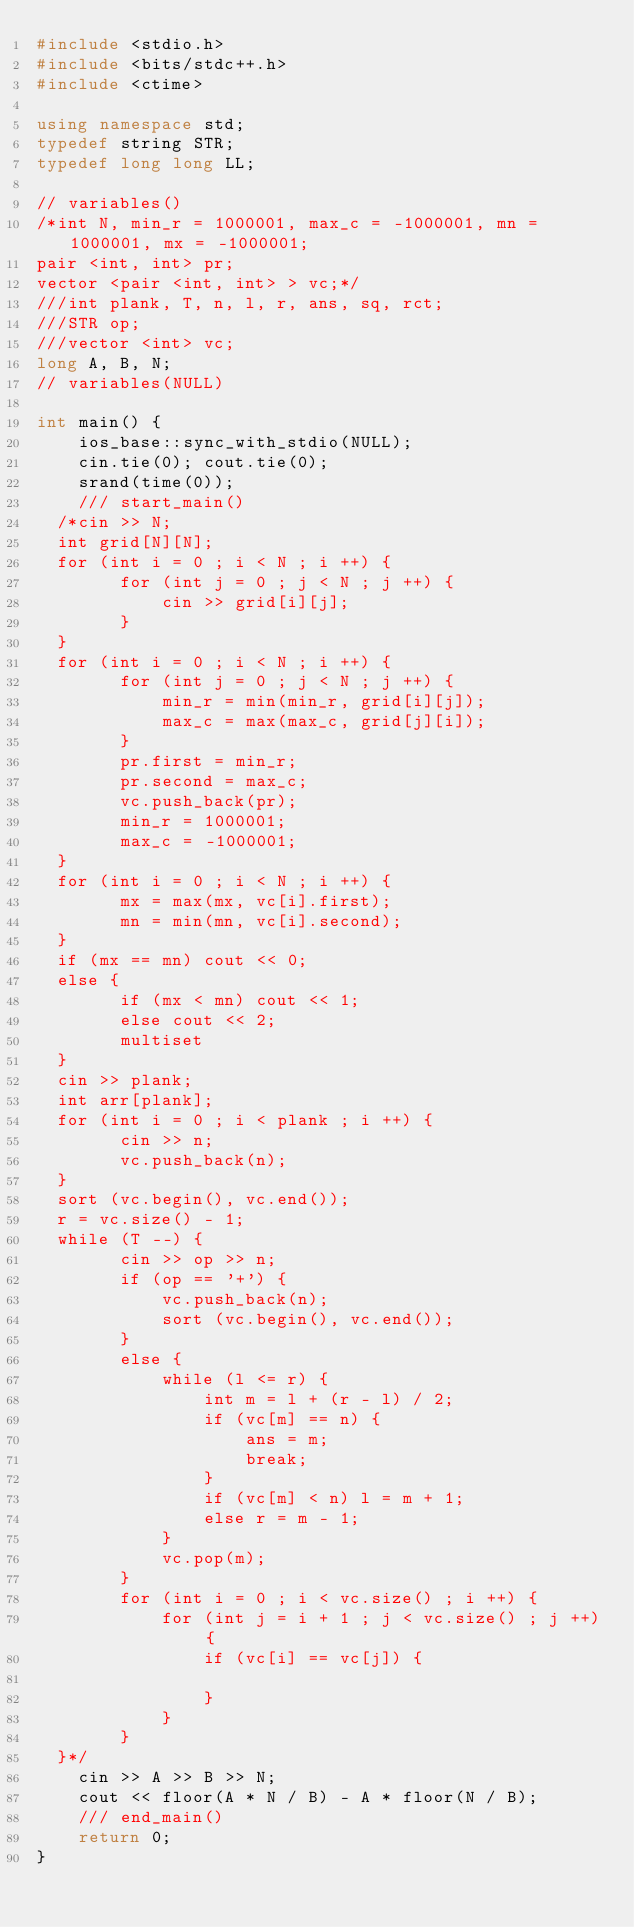<code> <loc_0><loc_0><loc_500><loc_500><_C++_>#include <stdio.h>
#include <bits/stdc++.h>
#include <ctime>

using namespace std;
typedef string STR;
typedef long long LL;

// variables()
/*int N, min_r = 1000001, max_c = -1000001, mn = 1000001, mx = -1000001;
pair <int, int> pr;
vector <pair <int, int> > vc;*/
///int plank, T, n, l, r, ans, sq, rct;
///STR op;
///vector <int> vc;
long A, B, N;
// variables(NULL)

int main() {
    ios_base::sync_with_stdio(NULL);
    cin.tie(0); cout.tie(0);
    srand(time(0));
    /// start_main()
	/*cin >> N;
	int grid[N][N];
	for (int i = 0 ; i < N ; i ++) {
        for (int j = 0 ; j < N ; j ++) {
            cin >> grid[i][j];
        }
	}
	for (int i = 0 ; i < N ; i ++) {
        for (int j = 0 ; j < N ; j ++) {
            min_r = min(min_r, grid[i][j]);
            max_c = max(max_c, grid[j][i]);
        }
        pr.first = min_r;
        pr.second = max_c;
        vc.push_back(pr);
        min_r = 1000001;
        max_c = -1000001;
	}
	for (int i = 0 ; i < N ; i ++) {
        mx = max(mx, vc[i].first);
        mn = min(mn, vc[i].second);
	}
	if (mx == mn) cout << 0;
	else {
        if (mx < mn) cout << 1;
        else cout << 2;
        multiset
	}
	cin >> plank;
	int arr[plank];
	for (int i = 0 ; i < plank ; i ++) {
        cin >> n;
        vc.push_back(n);
	}
	sort (vc.begin(), vc.end());
	r = vc.size() - 1;
	while (T --) {
        cin >> op >> n;
        if (op == '+') {
            vc.push_back(n);
            sort (vc.begin(), vc.end());
        }
        else {
            while (l <= r) {
                int m = l + (r - l) / 2;
                if (vc[m] == n) {
                    ans = m;
                    break;
                }
                if (vc[m] < n) l = m + 1;
                else r = m - 1;
            }
            vc.pop(m);
        }
        for (int i = 0 ; i < vc.size() ; i ++) {
            for (int j = i + 1 ; j < vc.size() ; j ++) {
                if (vc[i] == vc[j]) {

                }
            }
        }
	}*/
    cin >> A >> B >> N;
    cout << floor(A * N / B) - A * floor(N / B);
    /// end_main()
    return 0;
}

</code> 